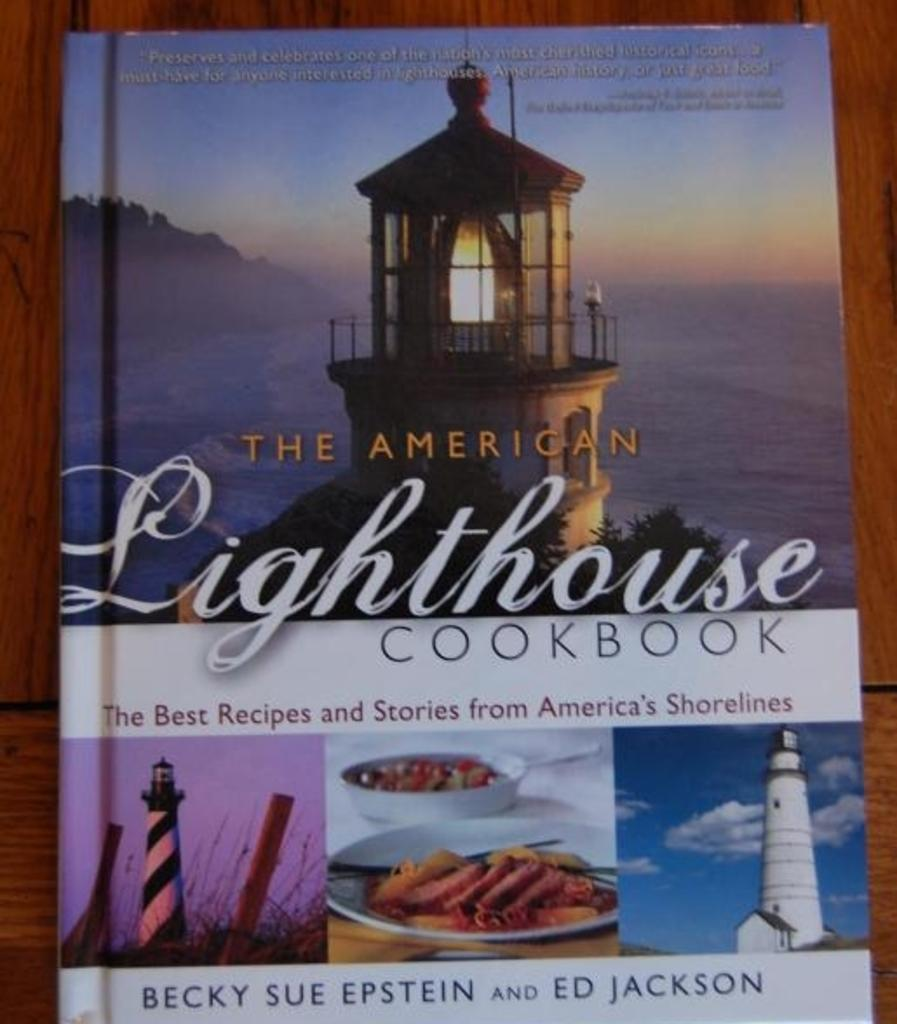<image>
Summarize the visual content of the image. The American Lighthouse Cookbook features recipes from America's shorelines. 